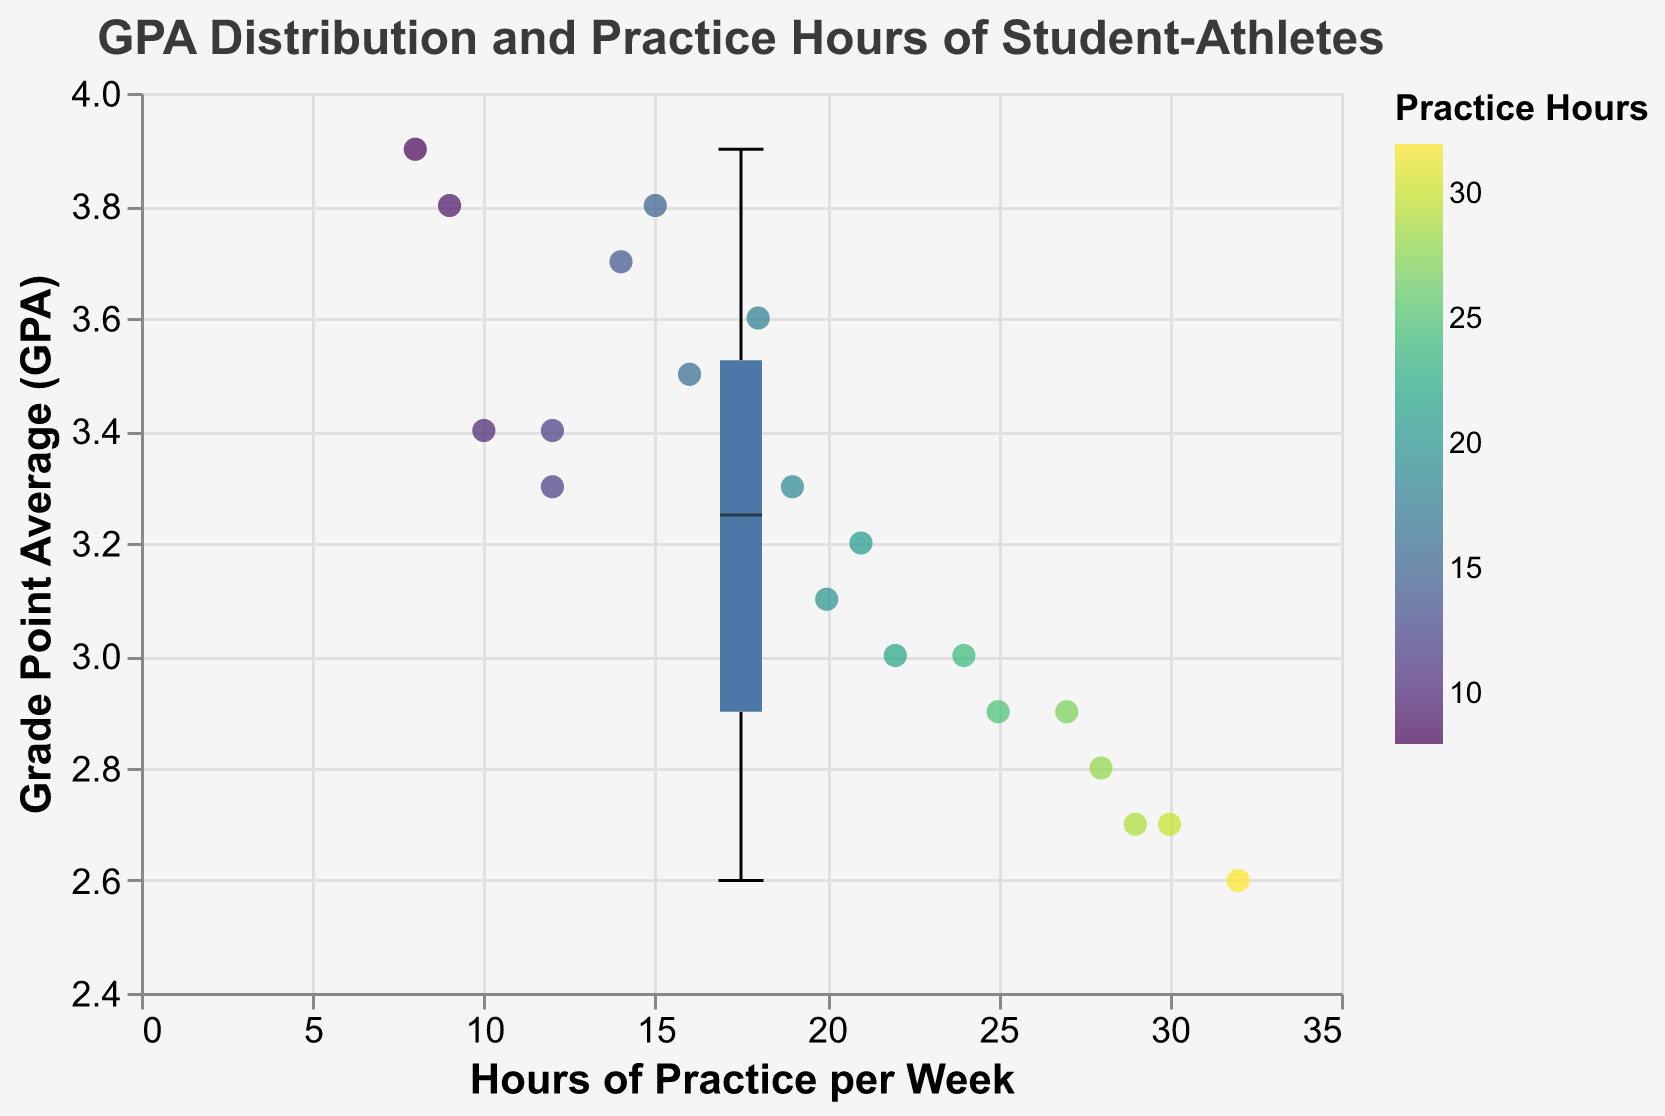What is the title of the figure? The title is usually located at the top of the figure and provides a brief description of what the plot represents.
Answer: GPA Distribution and Practice Hours of Student-Athletes What is the median GPA of the student-athletes? In a box plot, the median value is indicated by a line inside the box.
Answer: Approximately 3.3 What is the range of the Hours of Practice per Week? The range is defined as the difference between the maximum and minimum values on the x-axis. Since the x-axis shows Hours of Practice per Week with data points ranging from 8 to 32 hours.
Answer: 24 hours Which student-athlete has the lowest GPA and how many hours of practice do they have? To answer this, we need to find the minimum GPA value from the scatter points and look at the associated Hours of Practice tooltip. Nina Johnson has the lowest GPA of 2.6 and practices 32 hours per week.
Answer: Nina Johnson, 32 hours What is the interquartile range (IQR) of the GPA? The IQR is the range between the first quartile (Q1) and the third quartile (Q3) in a box plot. From the plot, estimate Q1 (around 2.9) and Q3 (around 3.6). Thus, IQR = Q3 - Q1.
Answer: 0.7 Is there any student-athlete with a GPA higher than 3.8? If yes, who and how many practice hours do they have? To answer this question, we need to inspect scatter points above the 3.8 GPA line. Isabella Martinez with a GPA of 3.9 and 8 hours of practice per week meets this criteria.
Answer: Isabella Martinez, 8 hours What is the upper whisker value of the GPA in the box plot? The upper whisker in a box plot usually indicates the maximum non-outlier GPA value, which extends to the maximum GPA value presented in the data.
Answer: Approximately 3.9 How many student-athletes practice more than 25 hours per week? Count the number of scatter points where the Hours_of_Practice_per_Week value is greater than 25. Bob Smith, Jack Brown, Nina Johnson, Tina Young, and Peter Davis meet this criteria.
Answer: 5 Compare the GPA of Bob Smith and Chris Evans. Who has a higher GPA and by how much? Look at the scatter points for Bob Smith and Chris Evans. Bob Smith's GPA is 2.9, and Chris Evans's GPA is 3.4. The difference is calculated as 3.4 - 2.9.
Answer: Chris Evans by 0.5 